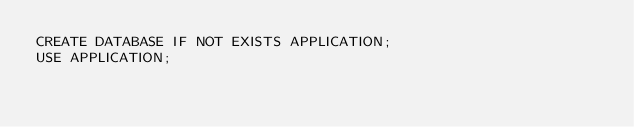Convert code to text. <code><loc_0><loc_0><loc_500><loc_500><_SQL_>CREATE DATABASE IF NOT EXISTS APPLICATION;
USE APPLICATION;
</code> 